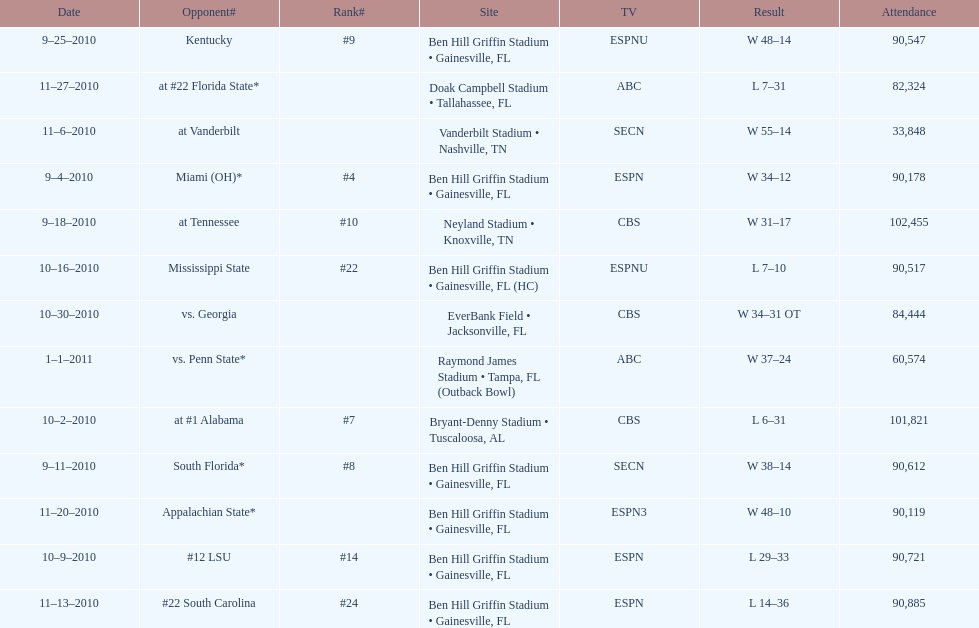What was the difference between the two scores of the last game? 13 points. 